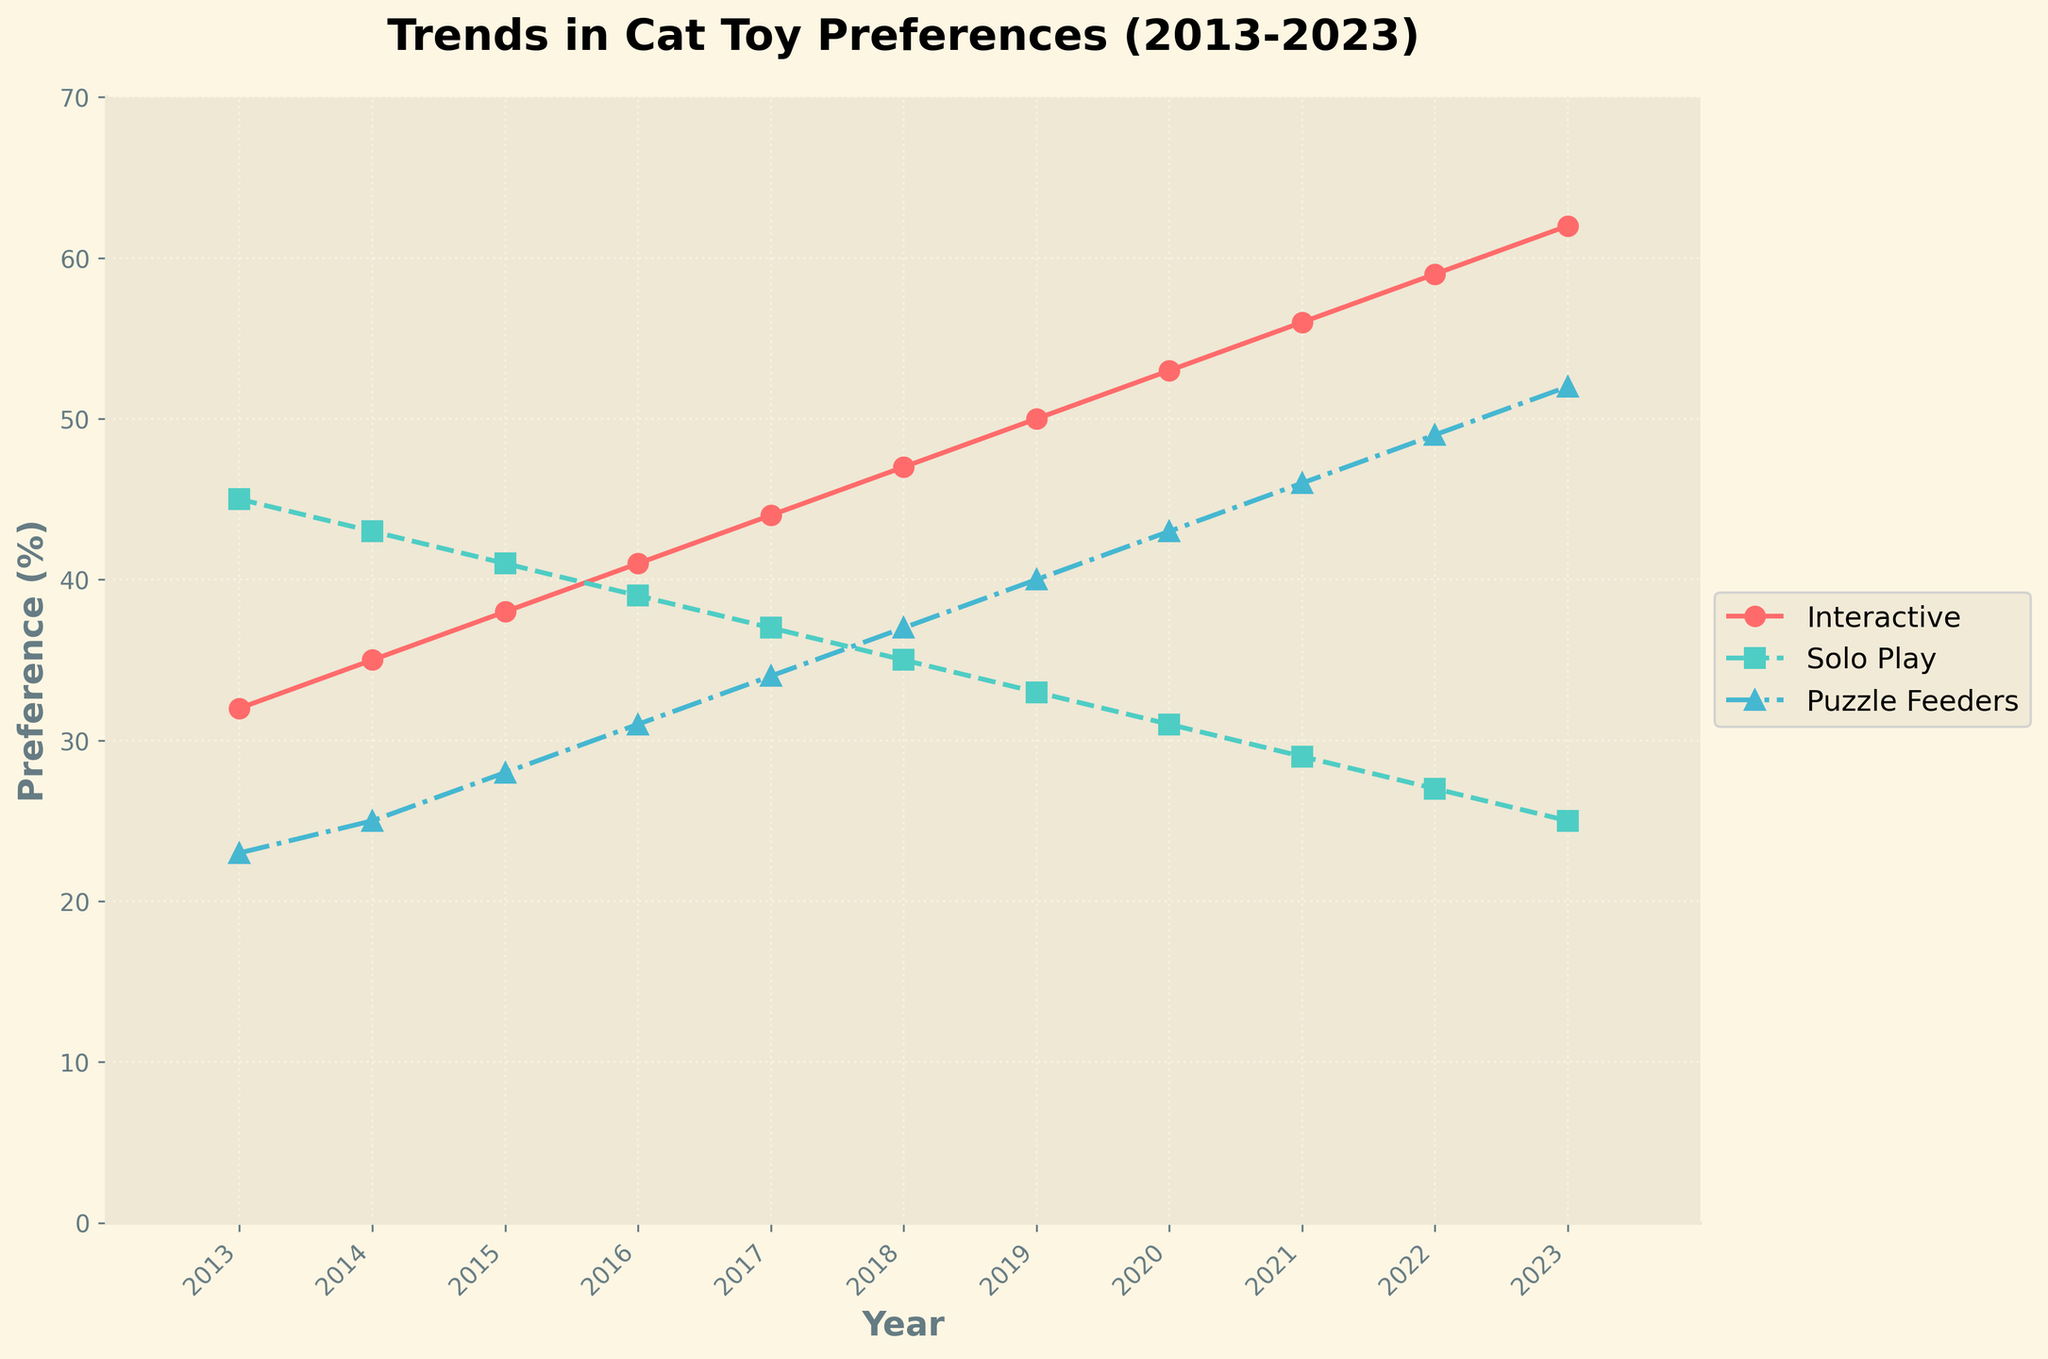What's the overall trend for interactive toys from 2013 to 2023? The line for interactive toys shows a consistent upward trend. It starts at 32% in 2013 and increases every year, reaching 62% in 2023.
Answer: Upward trend Which type of toy had the highest preference in 2019? In 2019, we can see the lines for each toy type. The interactive toys line is the highest at 50%, followed by solo play at 33% and puzzle feeders at 40%.
Answer: Interactive toys In which year did puzzle feeders overtook solo play toys in preference? By comparing the lines for solo play and puzzle feeders, puzzle feeders first overtook solo play in 2020. Puzzle feeders show a preference of 43% in 2020, while solo play is at 31%.
Answer: 2020 What's the difference in preference between solo play and interactive toys in 2018? In 2018, the preference for interactive toys is 47% and for solo play is 35%. The difference is 47% - 35% = 12%.
Answer: 12% What is the color used to represent solo play toys? The line representing solo play toys is marked with a green color.
Answer: Green By how much did the preference for interactive toys increase from 2013 to 2023? In 2013, interactive toys had a preference of 32%. In 2023, this increased to 62%. The increase is 62% - 32% = 30%.
Answer: 30% Which toy type showed the least variation in preference over the decade? The solo play toys exhibit the least variation. The preference decreases gradually from 45% in 2013 to 25% in 2023, while other toy types show more dynamic changes.
Answer: Solo play How does the preference for puzzle feeders in 2016 compare to interactive toys in the same year? In 2016, the preference for puzzle feeders is 31%, whereas for interactive toys it is 41%. So puzzle feeders have a lower preference compared to interactive toys in 2016.
Answer: Lower What's the average preference for puzzle feeders over the entire decade? The average is calculated by summing the preferences for puzzle feeders from 2013 to 2023 and dividing by the number of years. (23+25+28+31+34+37+40+43+46+49+52)/11 = 35.
Answer: 35 In which years were the preferences for solo play and puzzle feeders equal or nearly equal? By examining the lines for solo play and puzzle feeders, in 2020 both preferences are exactly 43%.
Answer: 2020 